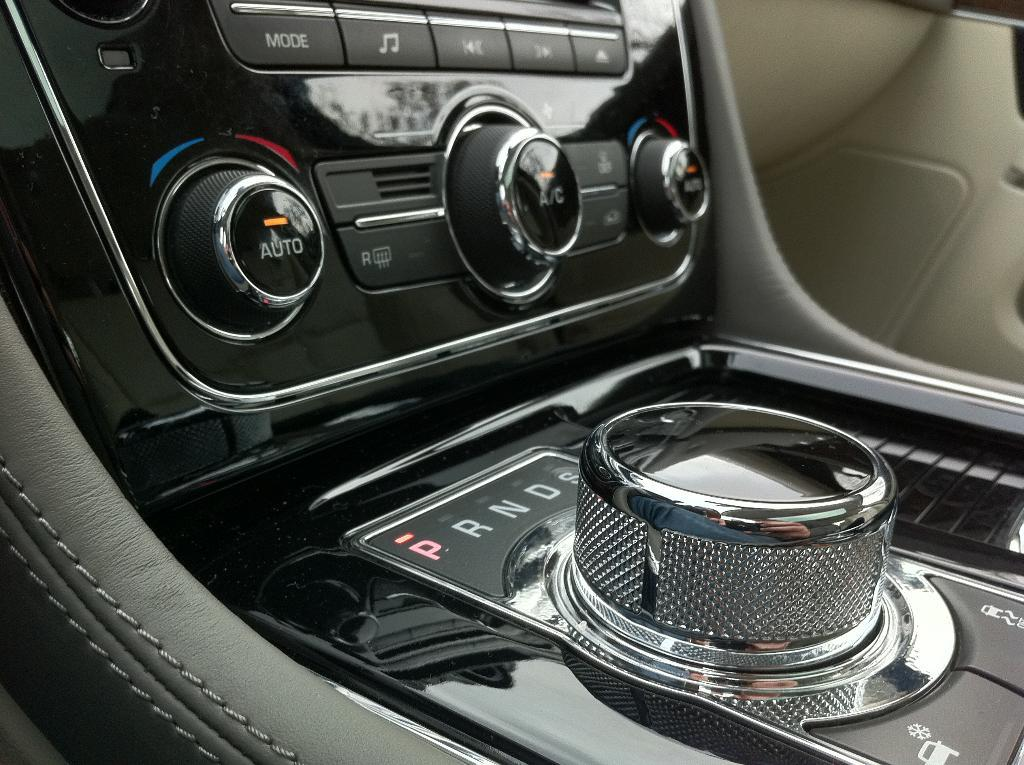What type of setting is depicted in the image? The image is an inside view of a vehicle. What type of controls or features can be seen in the image? There are buttons visible in the image. What else can be seen in the image besides the buttons? There is text visible in the image. Can you describe any other elements visible in the image? There are other unspecified elements visible in the image. What type of line can be seen connecting the jar to the mass in the image? There is no jar or mass present in the image; it is an inside view of a vehicle with buttons and text. 